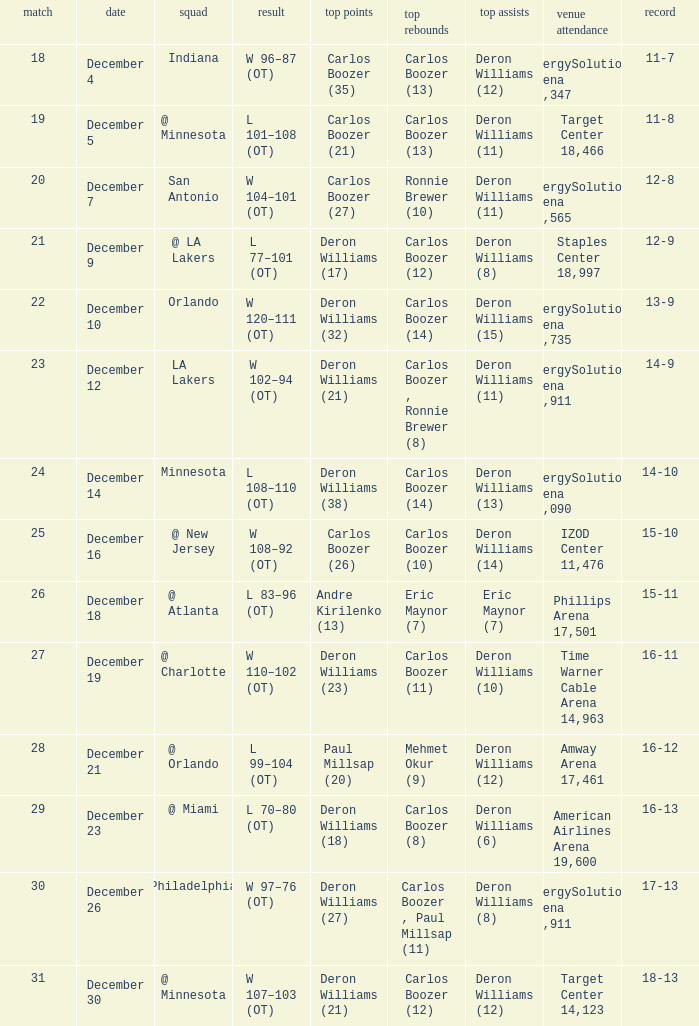Can you give me this table as a dict? {'header': ['match', 'date', 'squad', 'result', 'top points', 'top rebounds', 'top assists', 'venue attendance', 'record'], 'rows': [['18', 'December 4', 'Indiana', 'W 96–87 (OT)', 'Carlos Boozer (35)', 'Carlos Boozer (13)', 'Deron Williams (12)', 'EnergySolutions Arena 19,347', '11-7'], ['19', 'December 5', '@ Minnesota', 'L 101–108 (OT)', 'Carlos Boozer (21)', 'Carlos Boozer (13)', 'Deron Williams (11)', 'Target Center 18,466', '11-8'], ['20', 'December 7', 'San Antonio', 'W 104–101 (OT)', 'Carlos Boozer (27)', 'Ronnie Brewer (10)', 'Deron Williams (11)', 'EnergySolutions Arena 17,565', '12-8'], ['21', 'December 9', '@ LA Lakers', 'L 77–101 (OT)', 'Deron Williams (17)', 'Carlos Boozer (12)', 'Deron Williams (8)', 'Staples Center 18,997', '12-9'], ['22', 'December 10', 'Orlando', 'W 120–111 (OT)', 'Deron Williams (32)', 'Carlos Boozer (14)', 'Deron Williams (15)', 'EnergySolutions Arena 18,735', '13-9'], ['23', 'December 12', 'LA Lakers', 'W 102–94 (OT)', 'Deron Williams (21)', 'Carlos Boozer , Ronnie Brewer (8)', 'Deron Williams (11)', 'EnergySolutions Arena 19,911', '14-9'], ['24', 'December 14', 'Minnesota', 'L 108–110 (OT)', 'Deron Williams (38)', 'Carlos Boozer (14)', 'Deron Williams (13)', 'EnergySolutions Arena 18,090', '14-10'], ['25', 'December 16', '@ New Jersey', 'W 108–92 (OT)', 'Carlos Boozer (26)', 'Carlos Boozer (10)', 'Deron Williams (14)', 'IZOD Center 11,476', '15-10'], ['26', 'December 18', '@ Atlanta', 'L 83–96 (OT)', 'Andre Kirilenko (13)', 'Eric Maynor (7)', 'Eric Maynor (7)', 'Phillips Arena 17,501', '15-11'], ['27', 'December 19', '@ Charlotte', 'W 110–102 (OT)', 'Deron Williams (23)', 'Carlos Boozer (11)', 'Deron Williams (10)', 'Time Warner Cable Arena 14,963', '16-11'], ['28', 'December 21', '@ Orlando', 'L 99–104 (OT)', 'Paul Millsap (20)', 'Mehmet Okur (9)', 'Deron Williams (12)', 'Amway Arena 17,461', '16-12'], ['29', 'December 23', '@ Miami', 'L 70–80 (OT)', 'Deron Williams (18)', 'Carlos Boozer (8)', 'Deron Williams (6)', 'American Airlines Arena 19,600', '16-13'], ['30', 'December 26', 'Philadelphia', 'W 97–76 (OT)', 'Deron Williams (27)', 'Carlos Boozer , Paul Millsap (11)', 'Deron Williams (8)', 'EnergySolutions Arena 19,911', '17-13'], ['31', 'December 30', '@ Minnesota', 'W 107–103 (OT)', 'Deron Williams (21)', 'Carlos Boozer (12)', 'Deron Williams (12)', 'Target Center 14,123', '18-13']]} What's the number of the game in which Carlos Boozer (8) did the high rebounds? 29.0. 